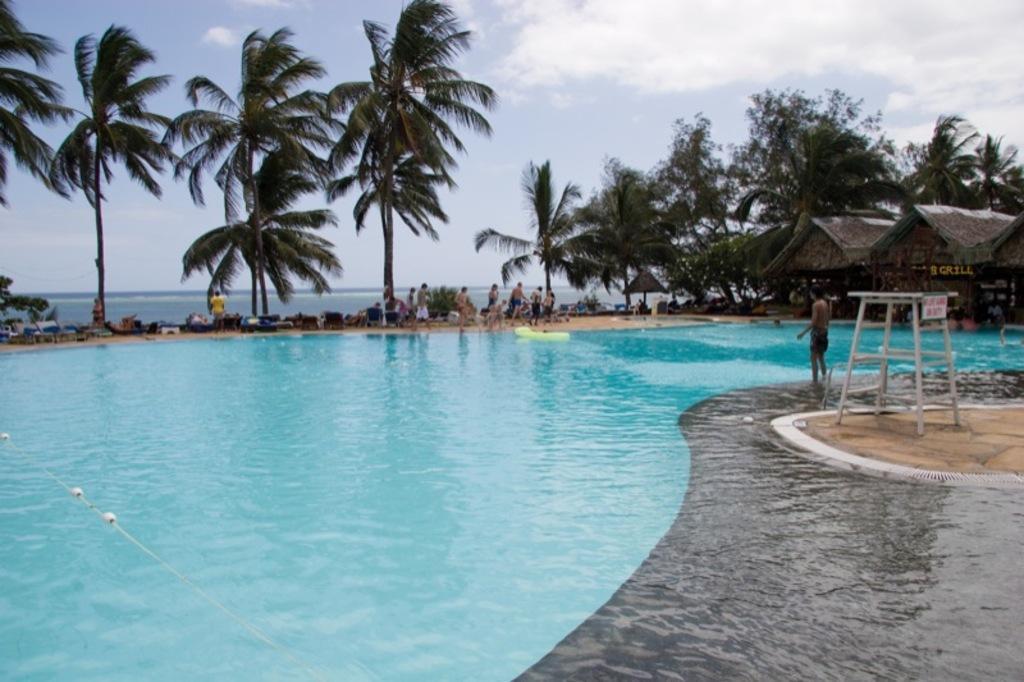Could you give a brief overview of what you see in this image? In the image we can see there are many people around. This is a swimming pool, trees, hot, water and a cloudy sky. This is an object. 